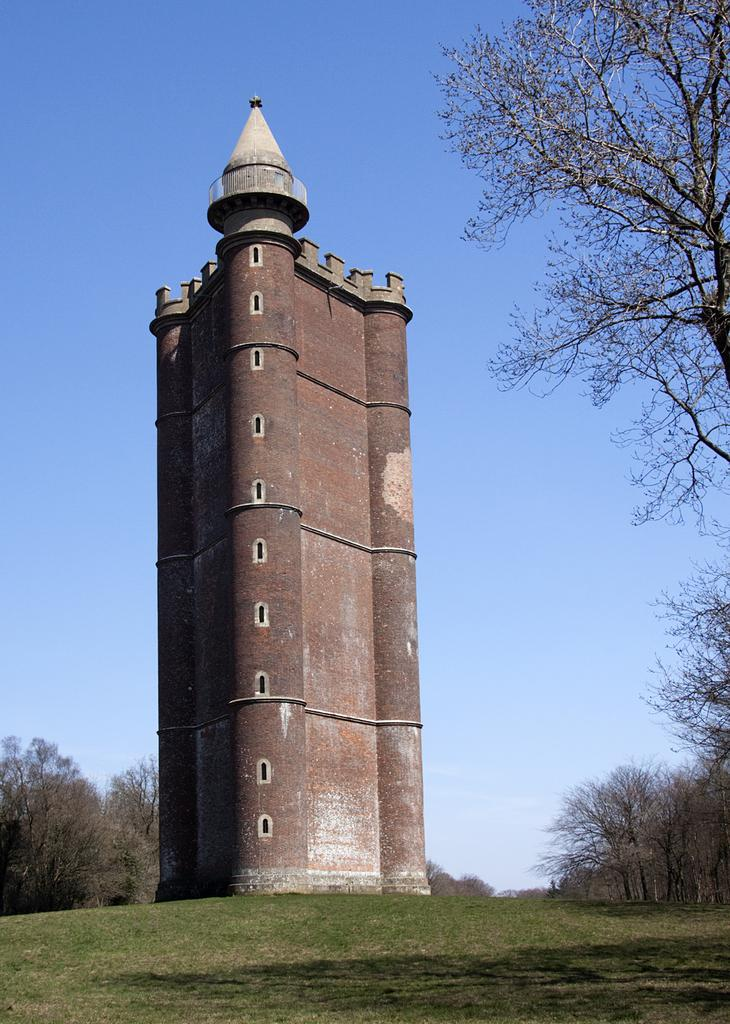What is the main structure in the middle of the image? There is a building in the middle of the image. What type of vegetation is present on both sides of the image? There are trees on either side of the image. What can be seen above the building and trees in the image? The sky is visible at the top of the image. What type of yarn is being used to decorate the building in the image? There is no yarn present in the image; it features a building, trees, and the sky. How many passengers are visible inside the building in the image? There are no passengers visible in the image, as it only shows the exterior of the building, trees, and the sky. 